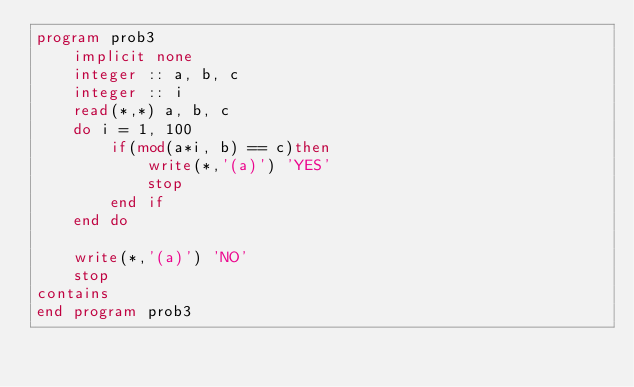Convert code to text. <code><loc_0><loc_0><loc_500><loc_500><_FORTRAN_>program prob3
    implicit none
    integer :: a, b, c
    integer :: i
    read(*,*) a, b, c
    do i = 1, 100
        if(mod(a*i, b) == c)then
            write(*,'(a)') 'YES'
            stop
        end if
    end do

    write(*,'(a)') 'NO'
    stop
contains
end program prob3</code> 